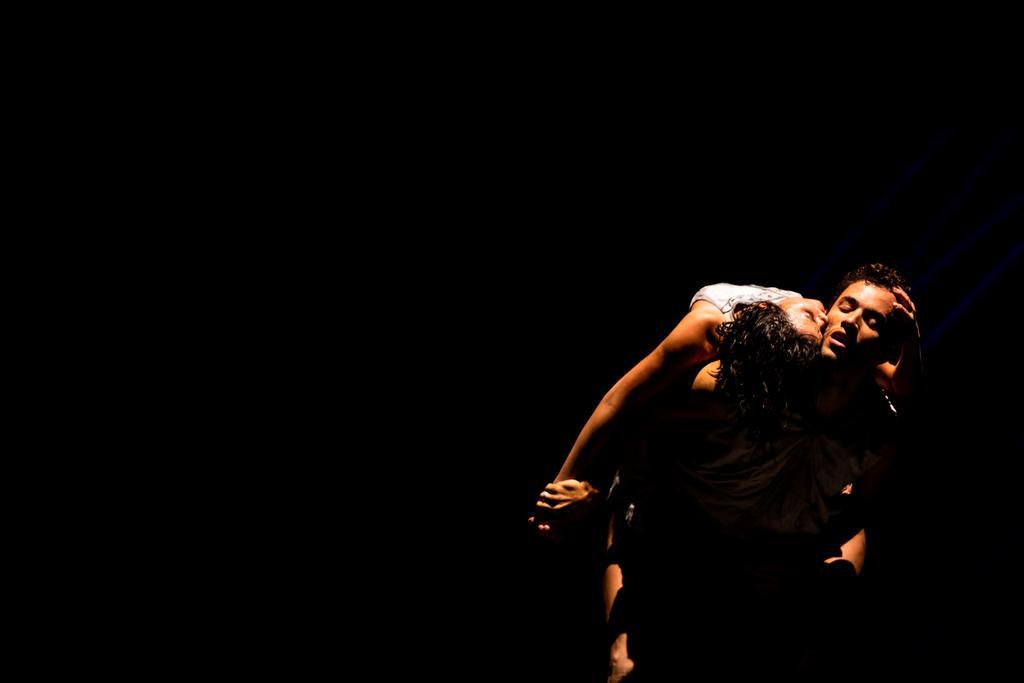In one or two sentences, can you explain what this image depicts? In this picture we can see two people and in the background it is dark. 